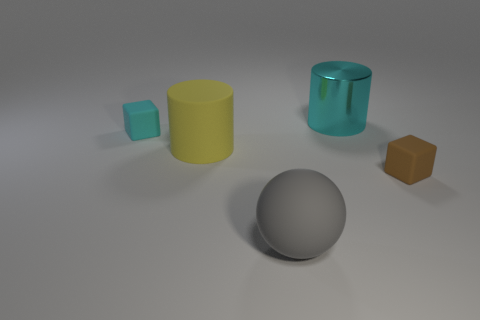Add 1 cyan blocks. How many objects exist? 6 Subtract all blocks. How many objects are left? 3 Add 3 metallic things. How many metallic things exist? 4 Subtract 0 green spheres. How many objects are left? 5 Subtract all green cylinders. Subtract all tiny cyan rubber cubes. How many objects are left? 4 Add 1 big metallic things. How many big metallic things are left? 2 